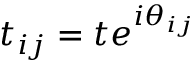Convert formula to latex. <formula><loc_0><loc_0><loc_500><loc_500>t _ { i j } = t e ^ { i \theta _ { i j } }</formula> 